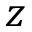<formula> <loc_0><loc_0><loc_500><loc_500>z</formula> 